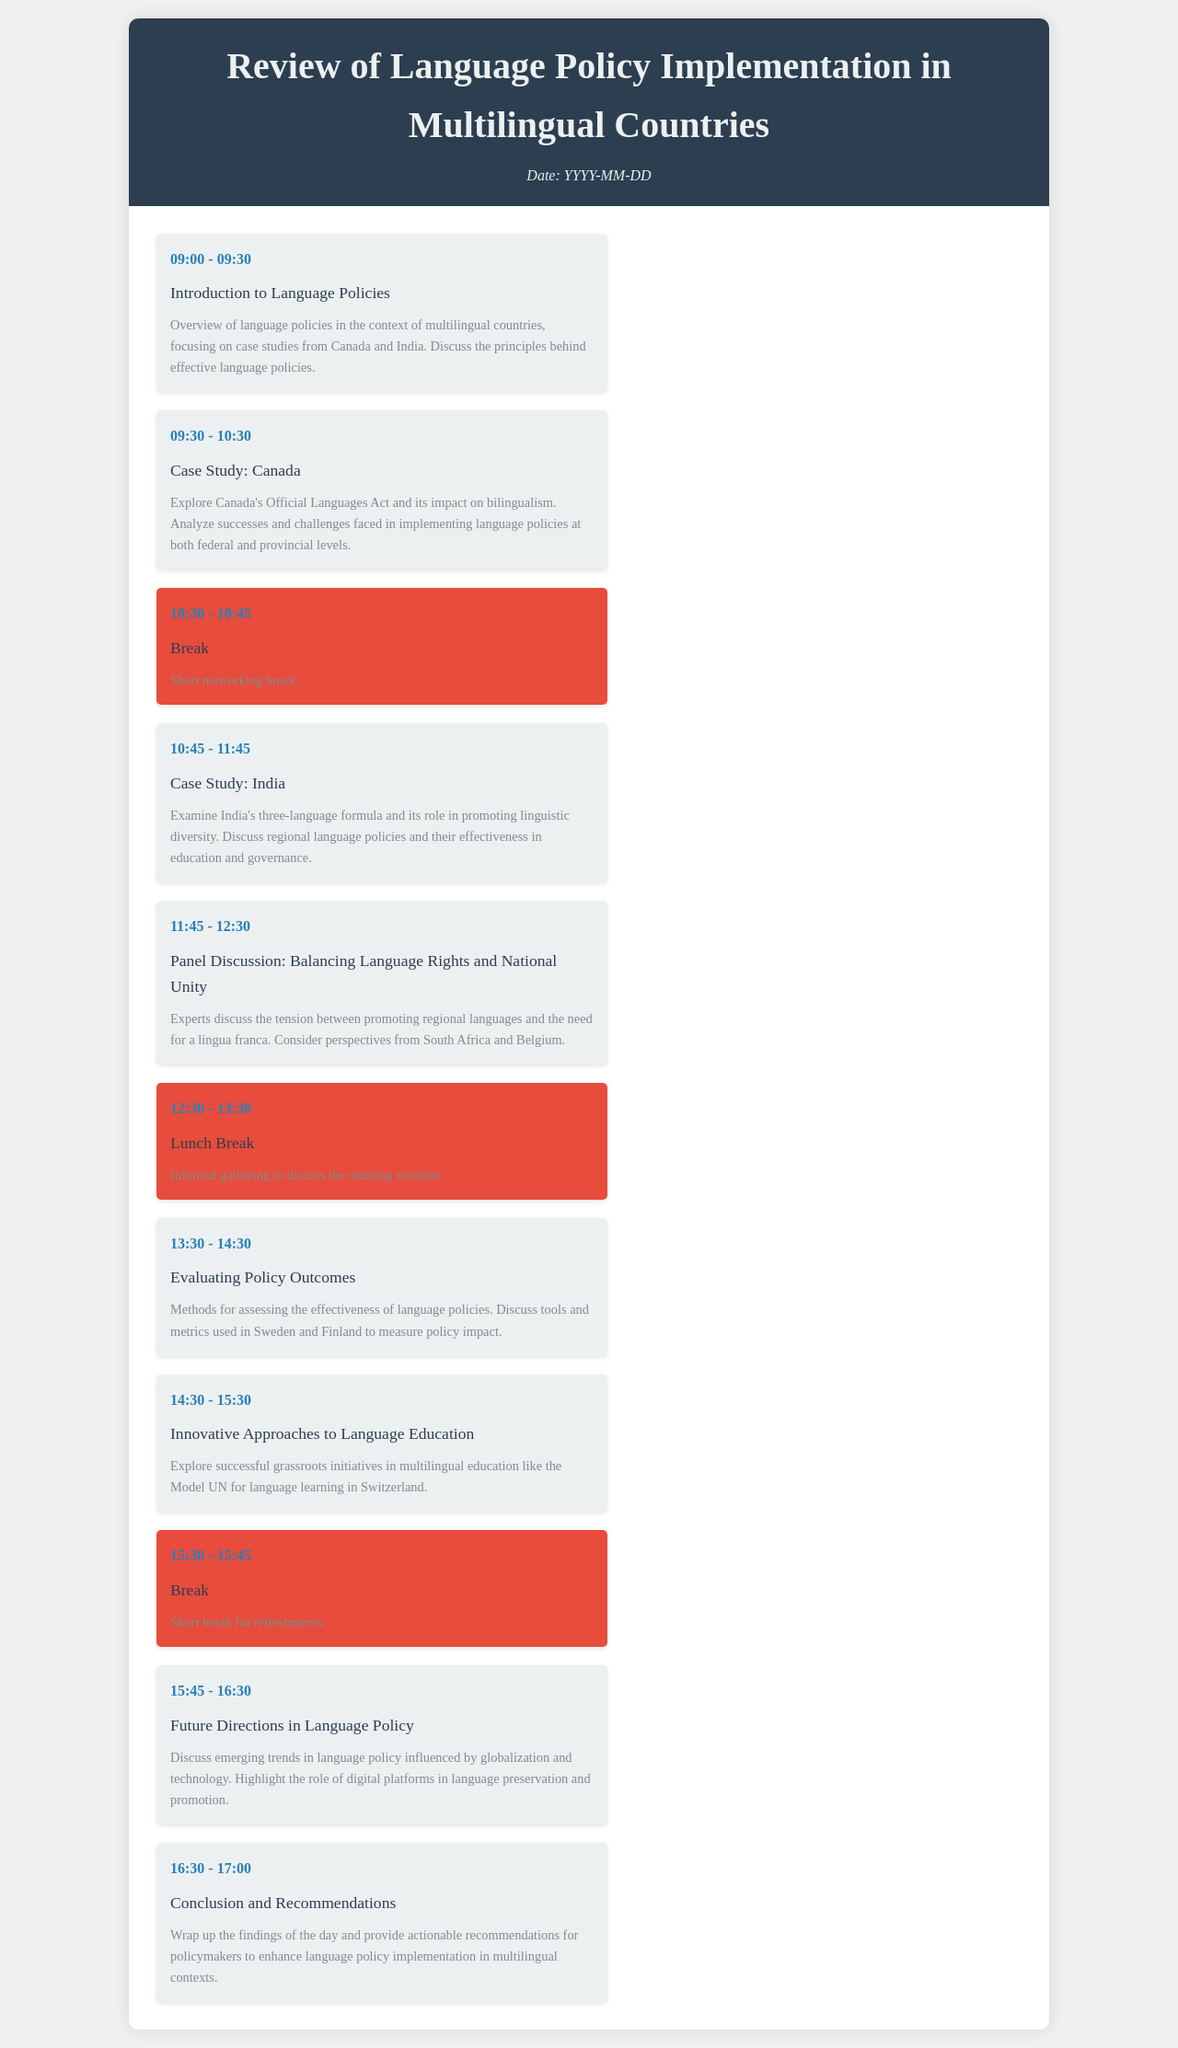What time does the introduction session start? The introduction session starts at 09:00.
Answer: 09:00 How long is the break after the case studies? The break after the case studies is 15 minutes long.
Answer: 15 minutes What is the main topic of the afternoon session at 13:30? The main topic of the afternoon session at 13:30 is evaluating policy outcomes.
Answer: Evaluating Policy Outcomes Which two countries are discussed in the case studies? The two countries discussed in the case studies are Canada and India.
Answer: Canada and India What is the focus of the panel discussion scheduled at 11:45? The focus of the panel discussion is balancing language rights and national unity.
Answer: Balancing Language Rights and National Unity What time does the final session conclude? The final session concludes at 17:00.
Answer: 17:00 How many sessions are there before lunch? There are four sessions before lunch.
Answer: Four sessions What innovative approach is explored for language education? The innovative approach explored is grassroots initiatives like the Model UN for language learning.
Answer: Model UN for language learning 